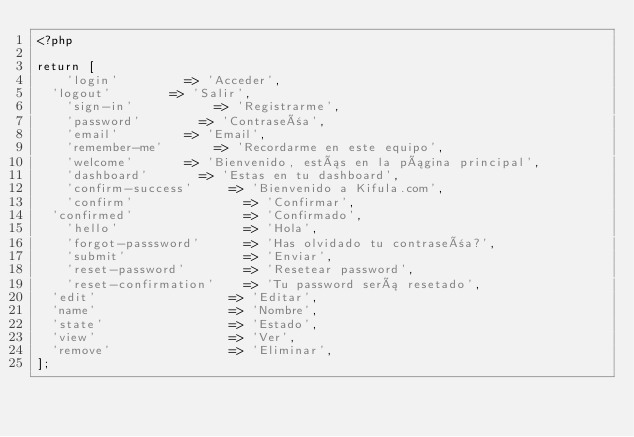Convert code to text. <code><loc_0><loc_0><loc_500><loc_500><_PHP_><?php

return [
    'login' 				=> 'Acceder',
	'logout'				=> 'Salir',
    'sign-in'       		=> 'Registrarme',
    'password' 				=> 'Contraseña',
    'email' 				=> 'Email',
    'remember-me' 			=> 'Recordarme en este equipo',
    'welcome'				=> 'Bienvenido, estás en la página principal',
    'dashboard' 			=> 'Estas en tu dashboard',
    'confirm-success' 		=> 'Bienvenido a Kifula.com',
    'confirm'               => 'Confirmar',
	'confirmed'               => 'Confirmado',
    'hello'                 => 'Hola',
    'forgot-passsword'      => 'Has olvidado tu contraseña?',
    'submit'                => 'Enviar',
    'reset-password'        => 'Resetear password',
    'reset-confirmation'    => 'Tu password será resetado',
	'edit'                  => 'Editar',
	'name'                  => 'Nombre',
	'state'                 => 'Estado',
	'view'                  => 'Ver',
	'remove'                => 'Eliminar',
];
</code> 